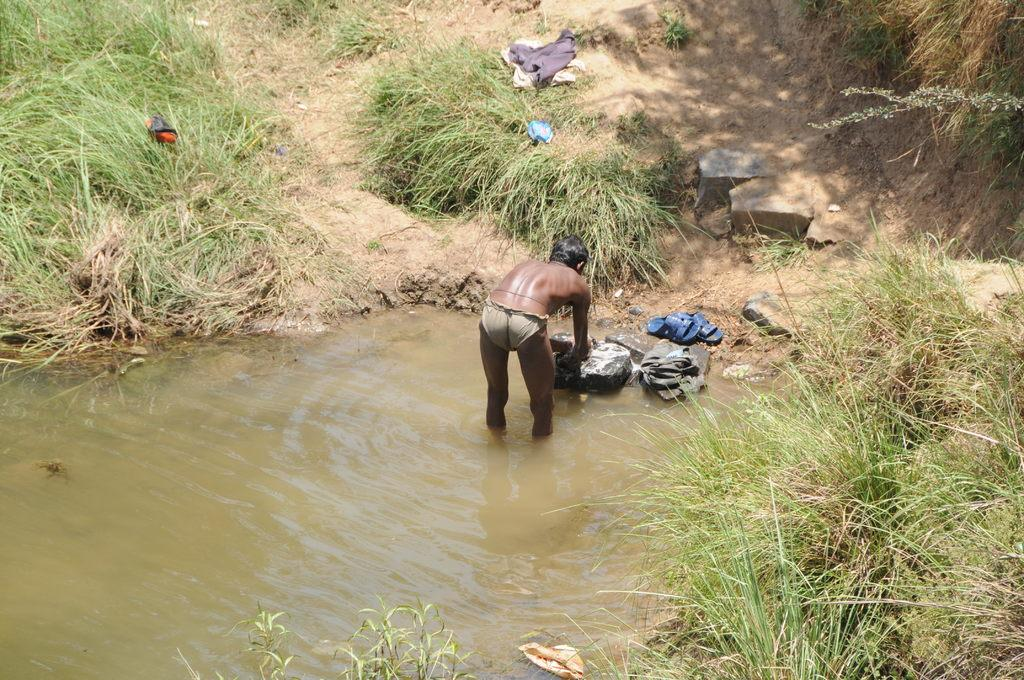What is at the bottom of the image? There is water and grass at the bottom of the image. What is the man in the image doing? The man is standing in the water. What is at the top of the image? There is grass and stones at the top of the image. Reasoning: Let' Let's think step by step in order to produce the conversation. We start by identifying the main subjects and objects in the image based on the provided facts. We then formulate questions that focus on the location and characteristics of these subjects and objects, ensuring that each question can be answered definitively with the information given. We avoid yes/no questions and ensure that the language is simple and clear. Absurd Question/Answer: What type of lock can be seen on the drum in the image? There is no drum or lock present in the image. How many bears are visible in the image? There are no bears present in the image. What type of lock can be seen on the drum in the image? There is no drum or lock present in the image. How many bears are visible in the image? There are no bears present in the image. 